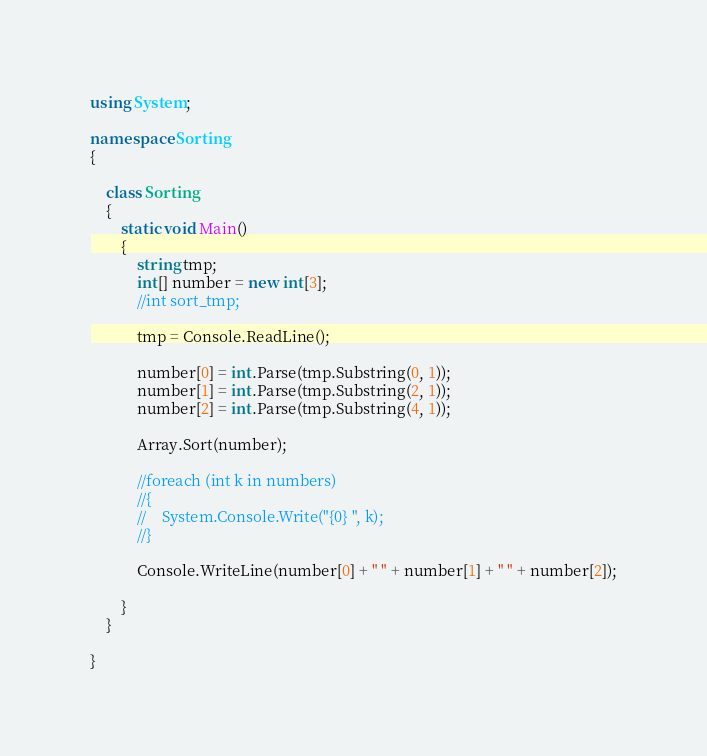<code> <loc_0><loc_0><loc_500><loc_500><_C#_>using System;

namespace Sorting
{

	class Sorting
	{
		static void Main()
		{
            string tmp;
            int[] number = new int[3];
            //int sort_tmp;

            tmp = Console.ReadLine();

            number[0] = int.Parse(tmp.Substring(0, 1));
            number[1] = int.Parse(tmp.Substring(2, 1));
            number[2] = int.Parse(tmp.Substring(4, 1));

            Array.Sort(number);

            //foreach (int k in numbers)
			//{
			//    System.Console.Write("{0} ", k);
			//}

			Console.WriteLine(number[0] + " " + number[1] + " " + number[2]);

		}
	}

}</code> 